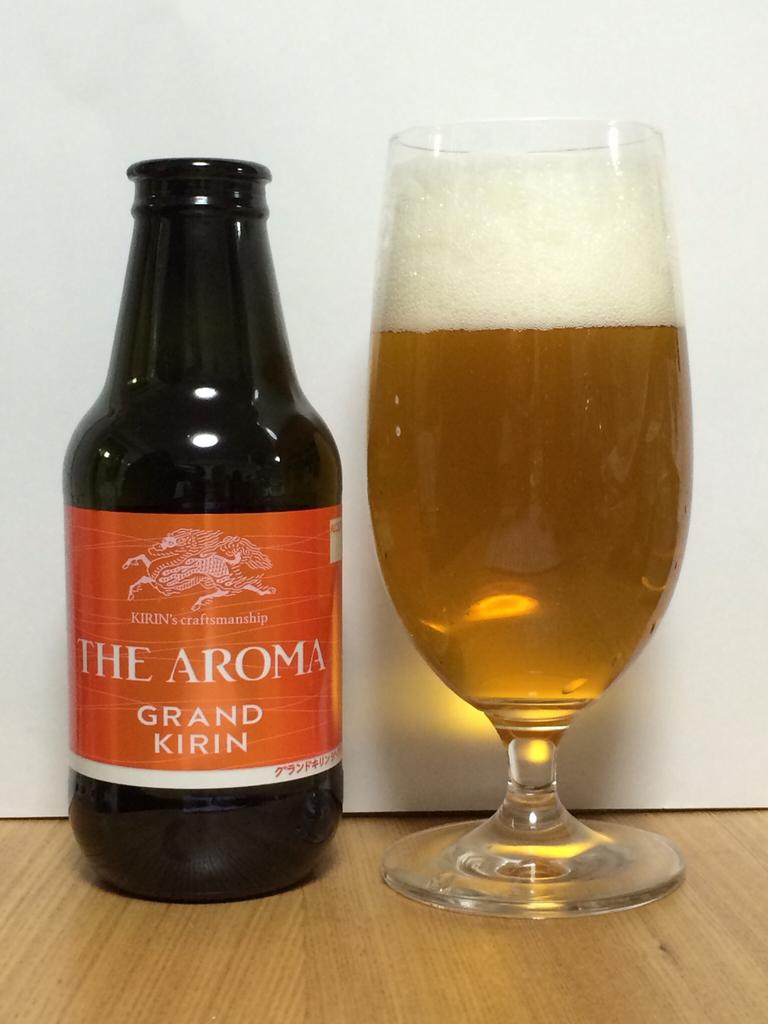What is the name of this drink?
Offer a terse response. The aroma. 